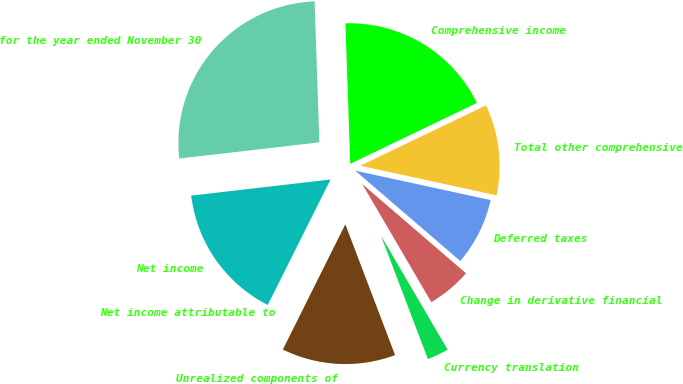Convert chart. <chart><loc_0><loc_0><loc_500><loc_500><pie_chart><fcel>for the year ended November 30<fcel>Net income<fcel>Net income attributable to<fcel>Unrealized components of<fcel>Currency translation<fcel>Change in derivative financial<fcel>Deferred taxes<fcel>Total other comprehensive<fcel>Comprehensive income<nl><fcel>26.29%<fcel>15.78%<fcel>0.02%<fcel>13.15%<fcel>2.64%<fcel>5.27%<fcel>7.9%<fcel>10.53%<fcel>18.41%<nl></chart> 